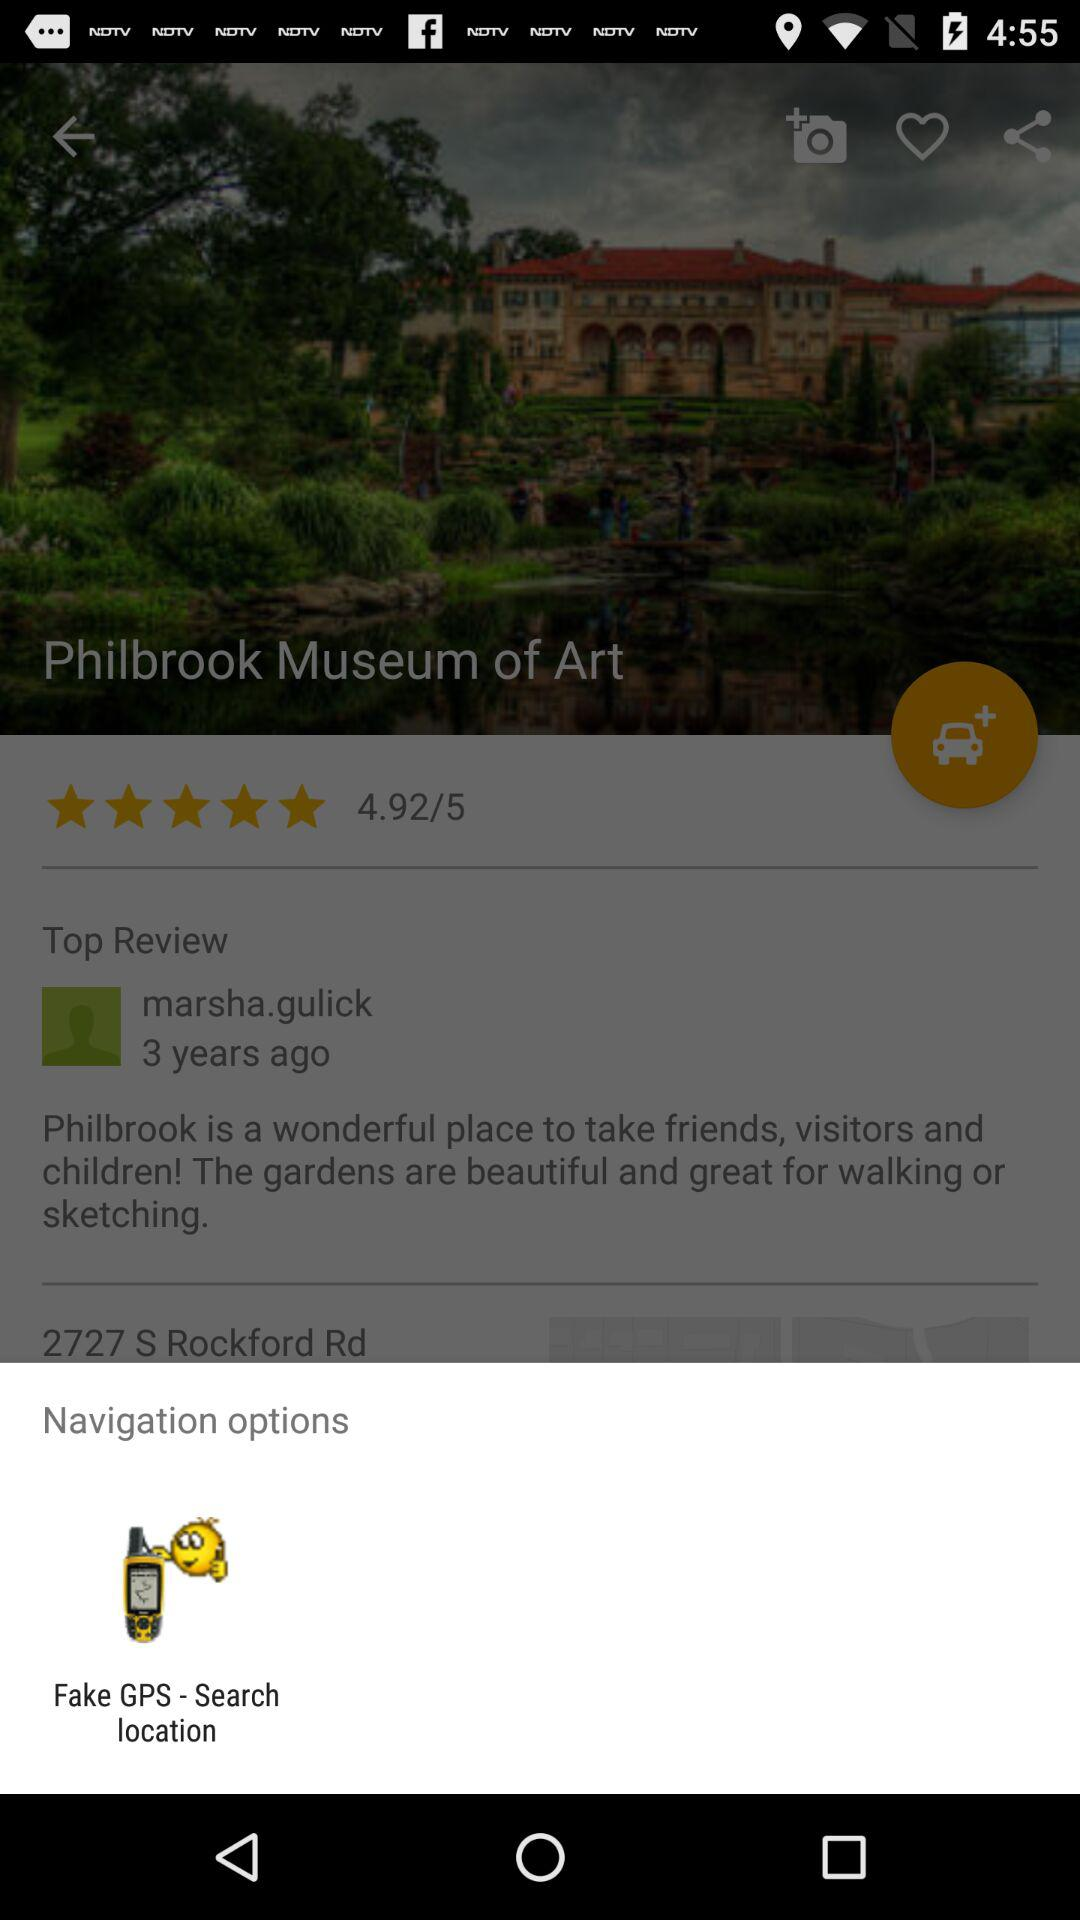How many people left reviews?
When the provided information is insufficient, respond with <no answer>. <no answer> 